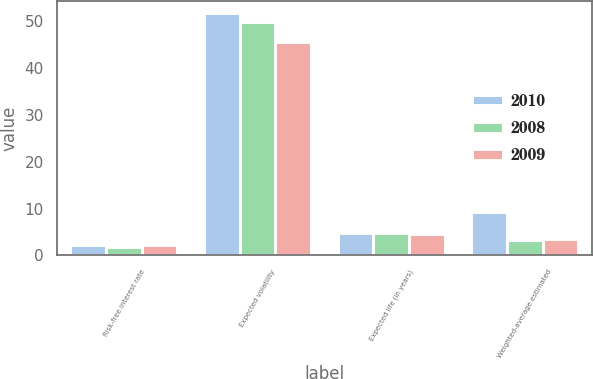<chart> <loc_0><loc_0><loc_500><loc_500><stacked_bar_chart><ecel><fcel>Risk-free interest rate<fcel>Expected volatility<fcel>Expected life (in years)<fcel>Weighted-average estimated<nl><fcel>2010<fcel>2.18<fcel>51.75<fcel>4.72<fcel>9.28<nl><fcel>2008<fcel>1.75<fcel>49.96<fcel>4.72<fcel>3.31<nl><fcel>2009<fcel>2.18<fcel>45.63<fcel>4.54<fcel>3.38<nl></chart> 